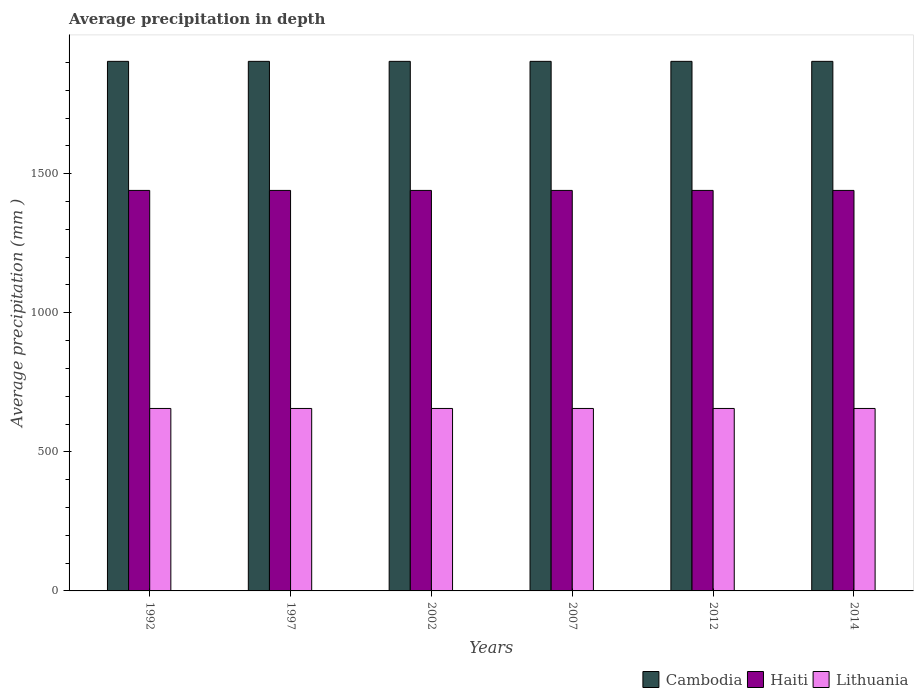In how many cases, is the number of bars for a given year not equal to the number of legend labels?
Make the answer very short. 0. What is the average precipitation in Haiti in 1997?
Offer a very short reply. 1440. Across all years, what is the maximum average precipitation in Haiti?
Ensure brevity in your answer.  1440. Across all years, what is the minimum average precipitation in Lithuania?
Make the answer very short. 656. In which year was the average precipitation in Lithuania maximum?
Provide a succinct answer. 1992. In which year was the average precipitation in Haiti minimum?
Your answer should be very brief. 1992. What is the total average precipitation in Cambodia in the graph?
Keep it short and to the point. 1.14e+04. What is the difference between the average precipitation in Haiti in 1992 and that in 2007?
Provide a short and direct response. 0. What is the difference between the average precipitation in Cambodia in 1997 and the average precipitation in Haiti in 2002?
Offer a very short reply. 464. What is the average average precipitation in Lithuania per year?
Your answer should be compact. 656. In the year 1992, what is the difference between the average precipitation in Haiti and average precipitation in Lithuania?
Provide a short and direct response. 784. In how many years, is the average precipitation in Cambodia greater than 1000 mm?
Your response must be concise. 6. What is the ratio of the average precipitation in Haiti in 1992 to that in 1997?
Ensure brevity in your answer.  1. Is the average precipitation in Haiti in 2007 less than that in 2012?
Keep it short and to the point. No. Is the difference between the average precipitation in Haiti in 2012 and 2014 greater than the difference between the average precipitation in Lithuania in 2012 and 2014?
Ensure brevity in your answer.  No. What is the difference between the highest and the second highest average precipitation in Haiti?
Provide a succinct answer. 0. What is the difference between the highest and the lowest average precipitation in Haiti?
Provide a short and direct response. 0. What does the 3rd bar from the left in 2007 represents?
Keep it short and to the point. Lithuania. What does the 1st bar from the right in 2002 represents?
Your response must be concise. Lithuania. Are all the bars in the graph horizontal?
Your answer should be compact. No. How many years are there in the graph?
Your response must be concise. 6. Does the graph contain grids?
Ensure brevity in your answer.  No. Where does the legend appear in the graph?
Keep it short and to the point. Bottom right. How are the legend labels stacked?
Provide a short and direct response. Horizontal. What is the title of the graph?
Your answer should be compact. Average precipitation in depth. Does "Kyrgyz Republic" appear as one of the legend labels in the graph?
Offer a terse response. No. What is the label or title of the X-axis?
Keep it short and to the point. Years. What is the label or title of the Y-axis?
Offer a terse response. Average precipitation (mm ). What is the Average precipitation (mm ) of Cambodia in 1992?
Ensure brevity in your answer.  1904. What is the Average precipitation (mm ) in Haiti in 1992?
Give a very brief answer. 1440. What is the Average precipitation (mm ) in Lithuania in 1992?
Make the answer very short. 656. What is the Average precipitation (mm ) in Cambodia in 1997?
Offer a terse response. 1904. What is the Average precipitation (mm ) of Haiti in 1997?
Give a very brief answer. 1440. What is the Average precipitation (mm ) of Lithuania in 1997?
Offer a terse response. 656. What is the Average precipitation (mm ) of Cambodia in 2002?
Your response must be concise. 1904. What is the Average precipitation (mm ) of Haiti in 2002?
Provide a short and direct response. 1440. What is the Average precipitation (mm ) in Lithuania in 2002?
Your answer should be very brief. 656. What is the Average precipitation (mm ) of Cambodia in 2007?
Your response must be concise. 1904. What is the Average precipitation (mm ) in Haiti in 2007?
Keep it short and to the point. 1440. What is the Average precipitation (mm ) in Lithuania in 2007?
Offer a very short reply. 656. What is the Average precipitation (mm ) of Cambodia in 2012?
Keep it short and to the point. 1904. What is the Average precipitation (mm ) in Haiti in 2012?
Provide a succinct answer. 1440. What is the Average precipitation (mm ) in Lithuania in 2012?
Ensure brevity in your answer.  656. What is the Average precipitation (mm ) in Cambodia in 2014?
Make the answer very short. 1904. What is the Average precipitation (mm ) in Haiti in 2014?
Provide a succinct answer. 1440. What is the Average precipitation (mm ) of Lithuania in 2014?
Your answer should be compact. 656. Across all years, what is the maximum Average precipitation (mm ) in Cambodia?
Give a very brief answer. 1904. Across all years, what is the maximum Average precipitation (mm ) of Haiti?
Your answer should be compact. 1440. Across all years, what is the maximum Average precipitation (mm ) of Lithuania?
Provide a succinct answer. 656. Across all years, what is the minimum Average precipitation (mm ) of Cambodia?
Give a very brief answer. 1904. Across all years, what is the minimum Average precipitation (mm ) in Haiti?
Provide a short and direct response. 1440. Across all years, what is the minimum Average precipitation (mm ) of Lithuania?
Provide a succinct answer. 656. What is the total Average precipitation (mm ) in Cambodia in the graph?
Keep it short and to the point. 1.14e+04. What is the total Average precipitation (mm ) of Haiti in the graph?
Provide a short and direct response. 8640. What is the total Average precipitation (mm ) of Lithuania in the graph?
Offer a very short reply. 3936. What is the difference between the Average precipitation (mm ) of Cambodia in 1992 and that in 1997?
Your answer should be very brief. 0. What is the difference between the Average precipitation (mm ) in Haiti in 1992 and that in 1997?
Provide a short and direct response. 0. What is the difference between the Average precipitation (mm ) in Haiti in 1992 and that in 2007?
Your response must be concise. 0. What is the difference between the Average precipitation (mm ) of Lithuania in 1992 and that in 2007?
Offer a very short reply. 0. What is the difference between the Average precipitation (mm ) of Cambodia in 1992 and that in 2012?
Provide a succinct answer. 0. What is the difference between the Average precipitation (mm ) of Haiti in 1992 and that in 2012?
Provide a succinct answer. 0. What is the difference between the Average precipitation (mm ) in Lithuania in 1992 and that in 2012?
Keep it short and to the point. 0. What is the difference between the Average precipitation (mm ) in Cambodia in 1997 and that in 2002?
Keep it short and to the point. 0. What is the difference between the Average precipitation (mm ) in Lithuania in 1997 and that in 2002?
Your response must be concise. 0. What is the difference between the Average precipitation (mm ) in Haiti in 1997 and that in 2007?
Ensure brevity in your answer.  0. What is the difference between the Average precipitation (mm ) of Cambodia in 1997 and that in 2012?
Ensure brevity in your answer.  0. What is the difference between the Average precipitation (mm ) in Haiti in 1997 and that in 2012?
Provide a short and direct response. 0. What is the difference between the Average precipitation (mm ) of Lithuania in 1997 and that in 2012?
Ensure brevity in your answer.  0. What is the difference between the Average precipitation (mm ) in Cambodia in 1997 and that in 2014?
Keep it short and to the point. 0. What is the difference between the Average precipitation (mm ) of Haiti in 1997 and that in 2014?
Provide a succinct answer. 0. What is the difference between the Average precipitation (mm ) in Haiti in 2002 and that in 2007?
Your answer should be very brief. 0. What is the difference between the Average precipitation (mm ) of Lithuania in 2002 and that in 2007?
Give a very brief answer. 0. What is the difference between the Average precipitation (mm ) of Cambodia in 2002 and that in 2012?
Keep it short and to the point. 0. What is the difference between the Average precipitation (mm ) in Haiti in 2002 and that in 2012?
Give a very brief answer. 0. What is the difference between the Average precipitation (mm ) of Lithuania in 2002 and that in 2014?
Give a very brief answer. 0. What is the difference between the Average precipitation (mm ) of Cambodia in 2007 and that in 2012?
Your answer should be very brief. 0. What is the difference between the Average precipitation (mm ) in Haiti in 2007 and that in 2012?
Ensure brevity in your answer.  0. What is the difference between the Average precipitation (mm ) in Lithuania in 2007 and that in 2012?
Offer a very short reply. 0. What is the difference between the Average precipitation (mm ) in Cambodia in 2007 and that in 2014?
Offer a very short reply. 0. What is the difference between the Average precipitation (mm ) in Haiti in 2007 and that in 2014?
Offer a terse response. 0. What is the difference between the Average precipitation (mm ) of Lithuania in 2007 and that in 2014?
Give a very brief answer. 0. What is the difference between the Average precipitation (mm ) in Cambodia in 2012 and that in 2014?
Keep it short and to the point. 0. What is the difference between the Average precipitation (mm ) of Haiti in 2012 and that in 2014?
Your response must be concise. 0. What is the difference between the Average precipitation (mm ) in Lithuania in 2012 and that in 2014?
Your answer should be very brief. 0. What is the difference between the Average precipitation (mm ) in Cambodia in 1992 and the Average precipitation (mm ) in Haiti in 1997?
Ensure brevity in your answer.  464. What is the difference between the Average precipitation (mm ) of Cambodia in 1992 and the Average precipitation (mm ) of Lithuania in 1997?
Provide a short and direct response. 1248. What is the difference between the Average precipitation (mm ) in Haiti in 1992 and the Average precipitation (mm ) in Lithuania in 1997?
Keep it short and to the point. 784. What is the difference between the Average precipitation (mm ) in Cambodia in 1992 and the Average precipitation (mm ) in Haiti in 2002?
Your answer should be very brief. 464. What is the difference between the Average precipitation (mm ) of Cambodia in 1992 and the Average precipitation (mm ) of Lithuania in 2002?
Ensure brevity in your answer.  1248. What is the difference between the Average precipitation (mm ) in Haiti in 1992 and the Average precipitation (mm ) in Lithuania in 2002?
Offer a terse response. 784. What is the difference between the Average precipitation (mm ) of Cambodia in 1992 and the Average precipitation (mm ) of Haiti in 2007?
Provide a succinct answer. 464. What is the difference between the Average precipitation (mm ) of Cambodia in 1992 and the Average precipitation (mm ) of Lithuania in 2007?
Keep it short and to the point. 1248. What is the difference between the Average precipitation (mm ) in Haiti in 1992 and the Average precipitation (mm ) in Lithuania in 2007?
Your answer should be compact. 784. What is the difference between the Average precipitation (mm ) of Cambodia in 1992 and the Average precipitation (mm ) of Haiti in 2012?
Your answer should be compact. 464. What is the difference between the Average precipitation (mm ) of Cambodia in 1992 and the Average precipitation (mm ) of Lithuania in 2012?
Your answer should be very brief. 1248. What is the difference between the Average precipitation (mm ) in Haiti in 1992 and the Average precipitation (mm ) in Lithuania in 2012?
Give a very brief answer. 784. What is the difference between the Average precipitation (mm ) in Cambodia in 1992 and the Average precipitation (mm ) in Haiti in 2014?
Ensure brevity in your answer.  464. What is the difference between the Average precipitation (mm ) of Cambodia in 1992 and the Average precipitation (mm ) of Lithuania in 2014?
Provide a short and direct response. 1248. What is the difference between the Average precipitation (mm ) in Haiti in 1992 and the Average precipitation (mm ) in Lithuania in 2014?
Your answer should be very brief. 784. What is the difference between the Average precipitation (mm ) in Cambodia in 1997 and the Average precipitation (mm ) in Haiti in 2002?
Keep it short and to the point. 464. What is the difference between the Average precipitation (mm ) in Cambodia in 1997 and the Average precipitation (mm ) in Lithuania in 2002?
Provide a short and direct response. 1248. What is the difference between the Average precipitation (mm ) in Haiti in 1997 and the Average precipitation (mm ) in Lithuania in 2002?
Keep it short and to the point. 784. What is the difference between the Average precipitation (mm ) in Cambodia in 1997 and the Average precipitation (mm ) in Haiti in 2007?
Offer a terse response. 464. What is the difference between the Average precipitation (mm ) of Cambodia in 1997 and the Average precipitation (mm ) of Lithuania in 2007?
Ensure brevity in your answer.  1248. What is the difference between the Average precipitation (mm ) of Haiti in 1997 and the Average precipitation (mm ) of Lithuania in 2007?
Give a very brief answer. 784. What is the difference between the Average precipitation (mm ) in Cambodia in 1997 and the Average precipitation (mm ) in Haiti in 2012?
Make the answer very short. 464. What is the difference between the Average precipitation (mm ) in Cambodia in 1997 and the Average precipitation (mm ) in Lithuania in 2012?
Keep it short and to the point. 1248. What is the difference between the Average precipitation (mm ) of Haiti in 1997 and the Average precipitation (mm ) of Lithuania in 2012?
Offer a terse response. 784. What is the difference between the Average precipitation (mm ) in Cambodia in 1997 and the Average precipitation (mm ) in Haiti in 2014?
Give a very brief answer. 464. What is the difference between the Average precipitation (mm ) of Cambodia in 1997 and the Average precipitation (mm ) of Lithuania in 2014?
Provide a short and direct response. 1248. What is the difference between the Average precipitation (mm ) of Haiti in 1997 and the Average precipitation (mm ) of Lithuania in 2014?
Ensure brevity in your answer.  784. What is the difference between the Average precipitation (mm ) of Cambodia in 2002 and the Average precipitation (mm ) of Haiti in 2007?
Ensure brevity in your answer.  464. What is the difference between the Average precipitation (mm ) in Cambodia in 2002 and the Average precipitation (mm ) in Lithuania in 2007?
Your answer should be very brief. 1248. What is the difference between the Average precipitation (mm ) of Haiti in 2002 and the Average precipitation (mm ) of Lithuania in 2007?
Your answer should be compact. 784. What is the difference between the Average precipitation (mm ) of Cambodia in 2002 and the Average precipitation (mm ) of Haiti in 2012?
Offer a terse response. 464. What is the difference between the Average precipitation (mm ) in Cambodia in 2002 and the Average precipitation (mm ) in Lithuania in 2012?
Provide a succinct answer. 1248. What is the difference between the Average precipitation (mm ) of Haiti in 2002 and the Average precipitation (mm ) of Lithuania in 2012?
Provide a short and direct response. 784. What is the difference between the Average precipitation (mm ) of Cambodia in 2002 and the Average precipitation (mm ) of Haiti in 2014?
Give a very brief answer. 464. What is the difference between the Average precipitation (mm ) in Cambodia in 2002 and the Average precipitation (mm ) in Lithuania in 2014?
Your answer should be very brief. 1248. What is the difference between the Average precipitation (mm ) of Haiti in 2002 and the Average precipitation (mm ) of Lithuania in 2014?
Your answer should be very brief. 784. What is the difference between the Average precipitation (mm ) of Cambodia in 2007 and the Average precipitation (mm ) of Haiti in 2012?
Keep it short and to the point. 464. What is the difference between the Average precipitation (mm ) in Cambodia in 2007 and the Average precipitation (mm ) in Lithuania in 2012?
Provide a succinct answer. 1248. What is the difference between the Average precipitation (mm ) in Haiti in 2007 and the Average precipitation (mm ) in Lithuania in 2012?
Your answer should be very brief. 784. What is the difference between the Average precipitation (mm ) in Cambodia in 2007 and the Average precipitation (mm ) in Haiti in 2014?
Keep it short and to the point. 464. What is the difference between the Average precipitation (mm ) in Cambodia in 2007 and the Average precipitation (mm ) in Lithuania in 2014?
Your answer should be compact. 1248. What is the difference between the Average precipitation (mm ) of Haiti in 2007 and the Average precipitation (mm ) of Lithuania in 2014?
Give a very brief answer. 784. What is the difference between the Average precipitation (mm ) in Cambodia in 2012 and the Average precipitation (mm ) in Haiti in 2014?
Offer a very short reply. 464. What is the difference between the Average precipitation (mm ) in Cambodia in 2012 and the Average precipitation (mm ) in Lithuania in 2014?
Ensure brevity in your answer.  1248. What is the difference between the Average precipitation (mm ) of Haiti in 2012 and the Average precipitation (mm ) of Lithuania in 2014?
Your response must be concise. 784. What is the average Average precipitation (mm ) of Cambodia per year?
Provide a short and direct response. 1904. What is the average Average precipitation (mm ) of Haiti per year?
Offer a terse response. 1440. What is the average Average precipitation (mm ) of Lithuania per year?
Ensure brevity in your answer.  656. In the year 1992, what is the difference between the Average precipitation (mm ) in Cambodia and Average precipitation (mm ) in Haiti?
Your answer should be very brief. 464. In the year 1992, what is the difference between the Average precipitation (mm ) in Cambodia and Average precipitation (mm ) in Lithuania?
Your response must be concise. 1248. In the year 1992, what is the difference between the Average precipitation (mm ) in Haiti and Average precipitation (mm ) in Lithuania?
Offer a terse response. 784. In the year 1997, what is the difference between the Average precipitation (mm ) in Cambodia and Average precipitation (mm ) in Haiti?
Make the answer very short. 464. In the year 1997, what is the difference between the Average precipitation (mm ) of Cambodia and Average precipitation (mm ) of Lithuania?
Your answer should be very brief. 1248. In the year 1997, what is the difference between the Average precipitation (mm ) in Haiti and Average precipitation (mm ) in Lithuania?
Offer a terse response. 784. In the year 2002, what is the difference between the Average precipitation (mm ) of Cambodia and Average precipitation (mm ) of Haiti?
Provide a short and direct response. 464. In the year 2002, what is the difference between the Average precipitation (mm ) in Cambodia and Average precipitation (mm ) in Lithuania?
Your answer should be compact. 1248. In the year 2002, what is the difference between the Average precipitation (mm ) of Haiti and Average precipitation (mm ) of Lithuania?
Keep it short and to the point. 784. In the year 2007, what is the difference between the Average precipitation (mm ) of Cambodia and Average precipitation (mm ) of Haiti?
Make the answer very short. 464. In the year 2007, what is the difference between the Average precipitation (mm ) of Cambodia and Average precipitation (mm ) of Lithuania?
Make the answer very short. 1248. In the year 2007, what is the difference between the Average precipitation (mm ) of Haiti and Average precipitation (mm ) of Lithuania?
Provide a short and direct response. 784. In the year 2012, what is the difference between the Average precipitation (mm ) in Cambodia and Average precipitation (mm ) in Haiti?
Your answer should be very brief. 464. In the year 2012, what is the difference between the Average precipitation (mm ) in Cambodia and Average precipitation (mm ) in Lithuania?
Offer a terse response. 1248. In the year 2012, what is the difference between the Average precipitation (mm ) of Haiti and Average precipitation (mm ) of Lithuania?
Your answer should be very brief. 784. In the year 2014, what is the difference between the Average precipitation (mm ) of Cambodia and Average precipitation (mm ) of Haiti?
Offer a very short reply. 464. In the year 2014, what is the difference between the Average precipitation (mm ) in Cambodia and Average precipitation (mm ) in Lithuania?
Your answer should be compact. 1248. In the year 2014, what is the difference between the Average precipitation (mm ) in Haiti and Average precipitation (mm ) in Lithuania?
Offer a very short reply. 784. What is the ratio of the Average precipitation (mm ) in Cambodia in 1992 to that in 2002?
Your answer should be very brief. 1. What is the ratio of the Average precipitation (mm ) in Haiti in 1992 to that in 2002?
Keep it short and to the point. 1. What is the ratio of the Average precipitation (mm ) in Cambodia in 1992 to that in 2007?
Give a very brief answer. 1. What is the ratio of the Average precipitation (mm ) in Haiti in 1992 to that in 2007?
Your answer should be very brief. 1. What is the ratio of the Average precipitation (mm ) of Lithuania in 1992 to that in 2007?
Offer a very short reply. 1. What is the ratio of the Average precipitation (mm ) in Haiti in 1992 to that in 2014?
Make the answer very short. 1. What is the ratio of the Average precipitation (mm ) of Lithuania in 1997 to that in 2002?
Ensure brevity in your answer.  1. What is the ratio of the Average precipitation (mm ) in Cambodia in 1997 to that in 2007?
Your response must be concise. 1. What is the ratio of the Average precipitation (mm ) in Haiti in 1997 to that in 2007?
Keep it short and to the point. 1. What is the ratio of the Average precipitation (mm ) in Lithuania in 1997 to that in 2007?
Your response must be concise. 1. What is the ratio of the Average precipitation (mm ) in Haiti in 1997 to that in 2012?
Make the answer very short. 1. What is the ratio of the Average precipitation (mm ) in Lithuania in 1997 to that in 2012?
Make the answer very short. 1. What is the ratio of the Average precipitation (mm ) in Cambodia in 1997 to that in 2014?
Your answer should be compact. 1. What is the ratio of the Average precipitation (mm ) in Haiti in 1997 to that in 2014?
Your answer should be very brief. 1. What is the ratio of the Average precipitation (mm ) in Haiti in 2002 to that in 2007?
Make the answer very short. 1. What is the ratio of the Average precipitation (mm ) of Lithuania in 2002 to that in 2007?
Provide a short and direct response. 1. What is the ratio of the Average precipitation (mm ) of Cambodia in 2002 to that in 2012?
Make the answer very short. 1. What is the ratio of the Average precipitation (mm ) in Lithuania in 2002 to that in 2012?
Your answer should be very brief. 1. What is the ratio of the Average precipitation (mm ) of Haiti in 2002 to that in 2014?
Make the answer very short. 1. What is the ratio of the Average precipitation (mm ) in Lithuania in 2002 to that in 2014?
Your answer should be very brief. 1. What is the ratio of the Average precipitation (mm ) in Cambodia in 2007 to that in 2012?
Your answer should be compact. 1. What is the ratio of the Average precipitation (mm ) of Haiti in 2007 to that in 2012?
Your answer should be compact. 1. What is the ratio of the Average precipitation (mm ) in Haiti in 2007 to that in 2014?
Give a very brief answer. 1. What is the ratio of the Average precipitation (mm ) in Lithuania in 2007 to that in 2014?
Ensure brevity in your answer.  1. What is the difference between the highest and the second highest Average precipitation (mm ) of Lithuania?
Ensure brevity in your answer.  0. 